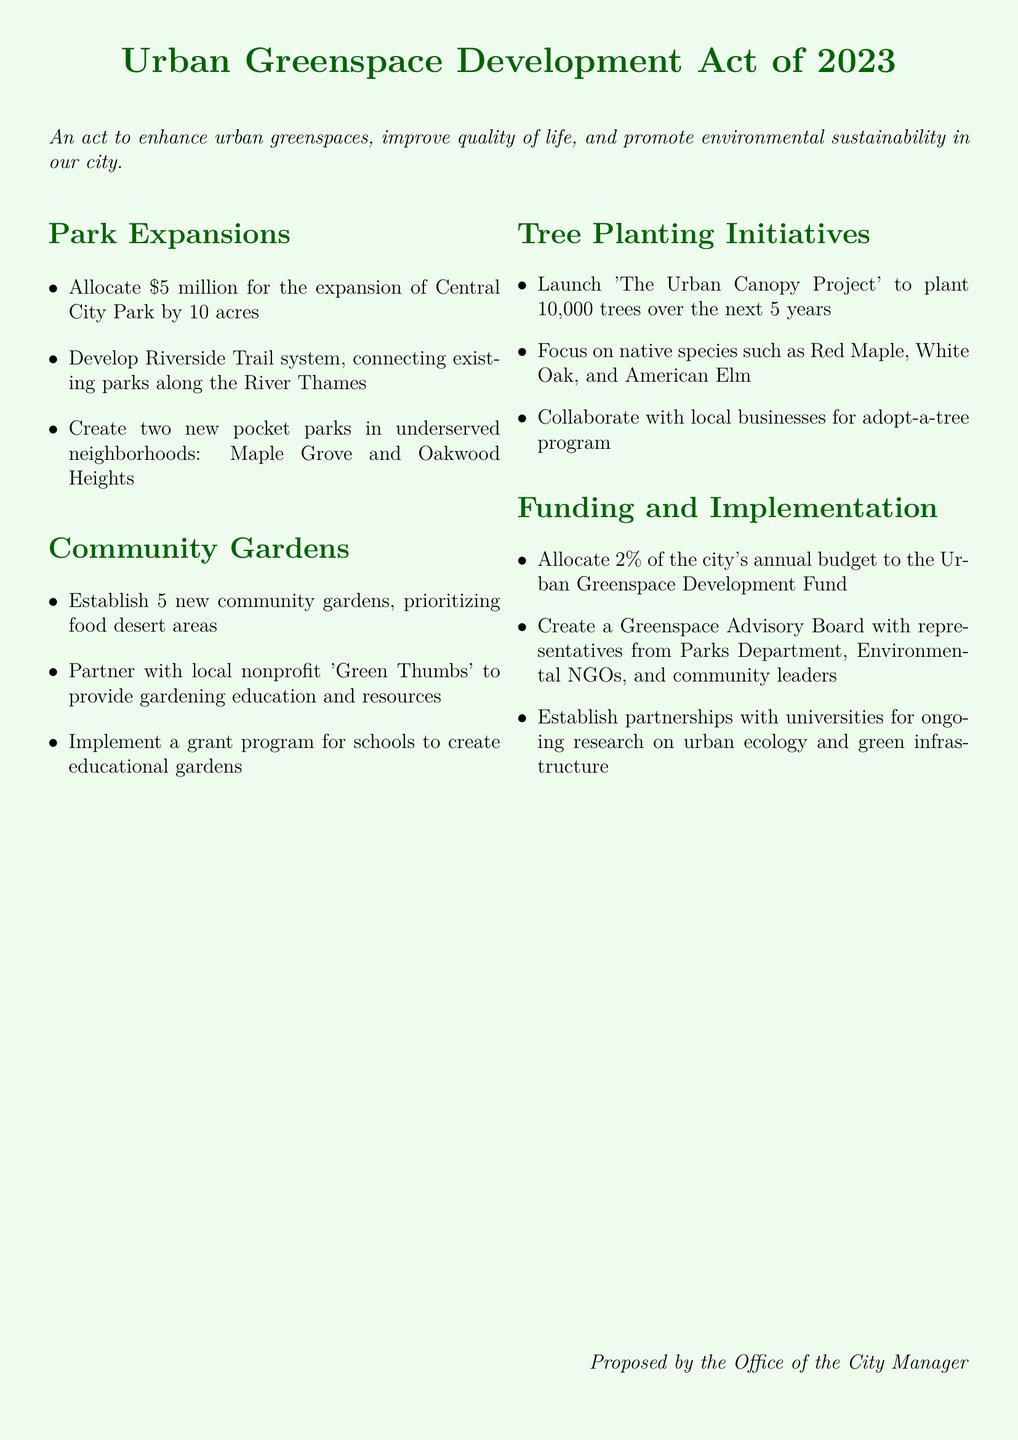What is the title of the bill? The title of the bill is stated prominently at the top of the document.
Answer: Urban Greenspace Development Act of 2023 How much funding is allocated for the expansion of Central City Park? The document specifies the amount allocated for park expansions.
Answer: 5 million How many new community gardens are proposed? The number of new community gardens is outlined in the community gardens section.
Answer: 5 What species of trees are focused on in 'The Urban Canopy Project'? The document lists the tree species targeted for planting in the initiative.
Answer: Red Maple, White Oak, American Elm What percentage of the city's annual budget is allocated to the Urban Greenspace Development Fund? The allocation percentage is mentioned in the funding section of the document.
Answer: 2% Which neighborhoods will have new pocket parks created? The neighborhoods are explicitly mentioned in the park expansions section.
Answer: Maple Grove, Oakwood Heights What organization is partnered with for gardening education? The name of the local nonprofit mentioned in the community gardens section is relevant here.
Answer: Green Thumbs What is the main goal of the Urban Greenspace Development Act? The purpose of the act is stated in the introductory sentence of the document.
Answer: Enhance urban greenspaces, improve quality of life, promote environmental sustainability How many trees does 'The Urban Canopy Project' aim to plant? The specific number of trees to be planted is detailed in the tree planting initiatives section.
Answer: 10,000 